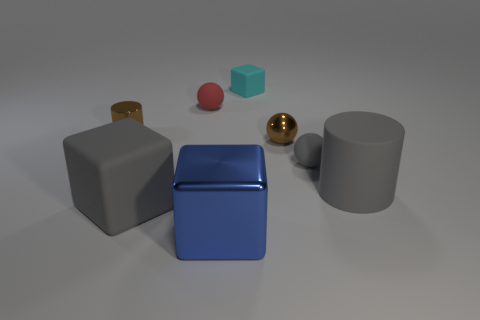Add 2 big gray rubber spheres. How many objects exist? 10 Subtract all cylinders. How many objects are left? 6 Subtract 1 blue blocks. How many objects are left? 7 Subtract all metallic balls. Subtract all gray matte cylinders. How many objects are left? 6 Add 5 matte balls. How many matte balls are left? 7 Add 3 tiny brown metallic blocks. How many tiny brown metallic blocks exist? 3 